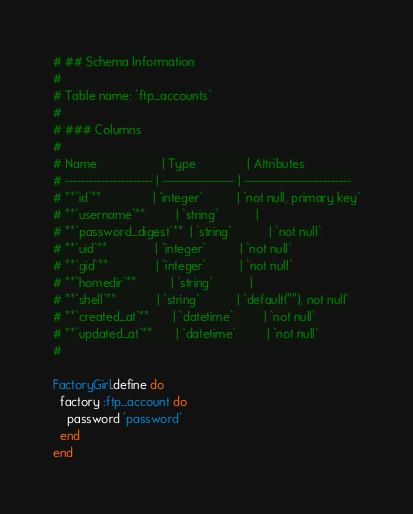<code> <loc_0><loc_0><loc_500><loc_500><_Ruby_># ## Schema Information
#
# Table name: `ftp_accounts`
#
# ### Columns
#
# Name                   | Type               | Attributes
# ---------------------- | ------------------ | ---------------------------
# **`id`**               | `integer`          | `not null, primary key`
# **`username`**         | `string`           |
# **`password_digest`**  | `string`           | `not null`
# **`uid`**              | `integer`          | `not null`
# **`gid`**              | `integer`          | `not null`
# **`homedir`**          | `string`           |
# **`shell`**            | `string`           | `default(""), not null`
# **`created_at`**       | `datetime`         | `not null`
# **`updated_at`**       | `datetime`         | `not null`
#

FactoryGirl.define do
  factory :ftp_account do
    password 'password'
  end
end
</code> 